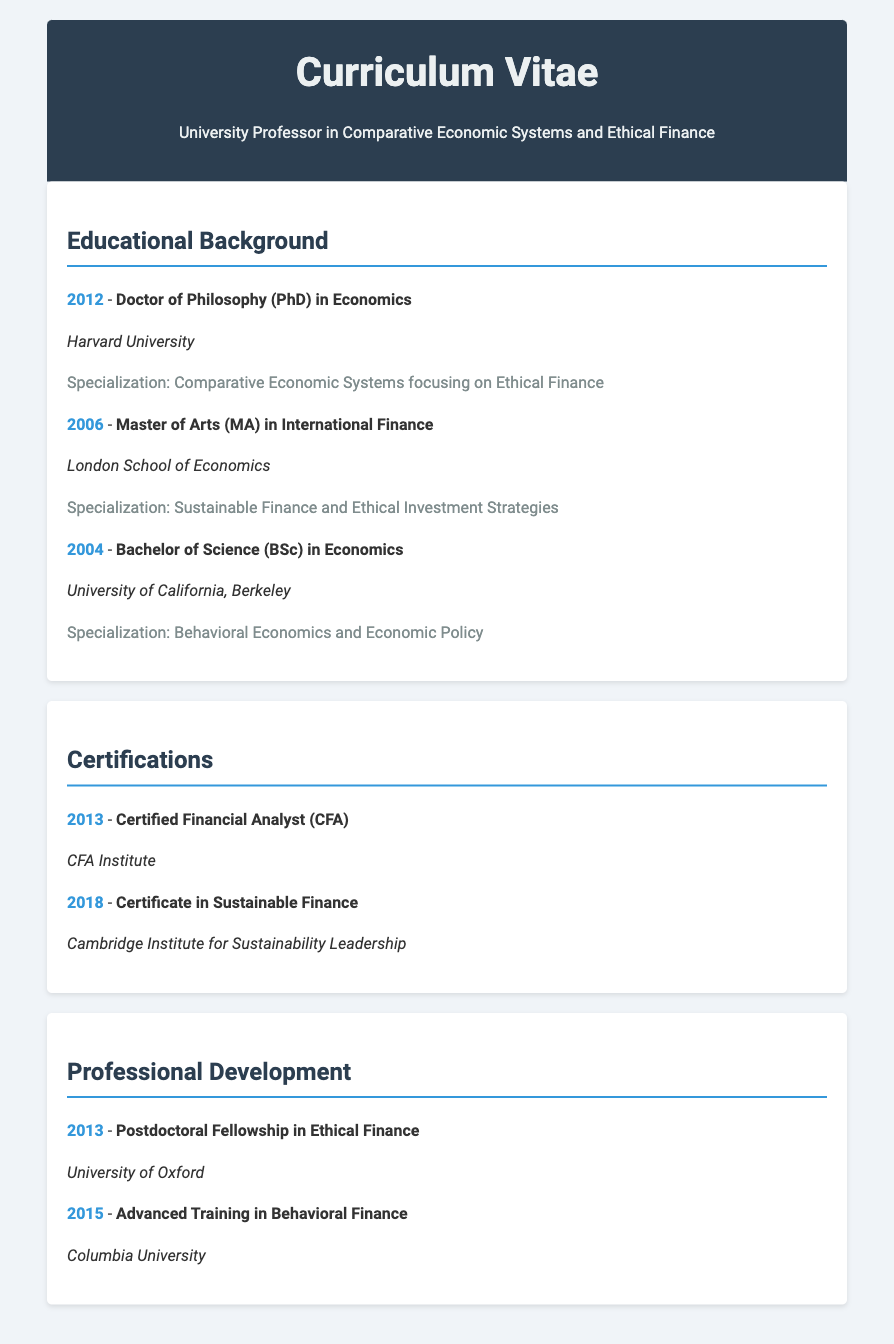What degree was earned in 2012? The document states that a Doctor of Philosophy (PhD) in Economics was earned in 2012.
Answer: Doctor of Philosophy (PhD) in Economics Which institution awarded the Master of Arts degree? The document specifies that the Master of Arts (MA) in International Finance was awarded by the London School of Economics.
Answer: London School of Economics What is the specialization of the Bachelor's degree? The specialization for the Bachelor of Science (BSc) in Economics is Behavioral Economics and Economic Policy as mentioned in the document.
Answer: Behavioral Economics and Economic Policy In what year did the author receive the Certified Financial Analyst certification? The document indicates that the Certified Financial Analyst (CFA) certification was received in 2013.
Answer: 2013 Which university offered the Postdoctoral Fellowship in Ethical Finance? According to the document, the Postdoctoral Fellowship in Ethical Finance was offered by the University of Oxford.
Answer: University of Oxford What is the specialization of the Master's degree? The specialization for the Master of Arts (MA) in International Finance is Sustainable Finance and Ethical Investment Strategies as detailed in the document.
Answer: Sustainable Finance and Ethical Investment Strategies How many degrees were earned in total? The document lists three degrees earned: PhD, MA, and BSc, totaling three degrees.
Answer: Three What was the area of specialization for the PhD? The document states that the specialization for the Doctor of Philosophy (PhD) was Comparative Economic Systems focusing on Ethical Finance.
Answer: Comparative Economic Systems focusing on Ethical Finance Which institution provided the Certificate in Sustainable Finance? The document specifies that the Certificate in Sustainable Finance was provided by the Cambridge Institute for Sustainability Leadership.
Answer: Cambridge Institute for Sustainability Leadership 